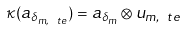<formula> <loc_0><loc_0><loc_500><loc_500>\kappa ( a _ { \delta _ { m , \ t e } } ) = a _ { \delta _ { m } } \otimes u _ { m , \ t e }</formula> 